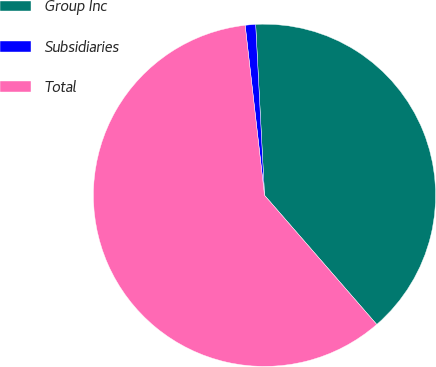<chart> <loc_0><loc_0><loc_500><loc_500><pie_chart><fcel>Group Inc<fcel>Subsidiaries<fcel>Total<nl><fcel>39.44%<fcel>0.98%<fcel>59.58%<nl></chart> 